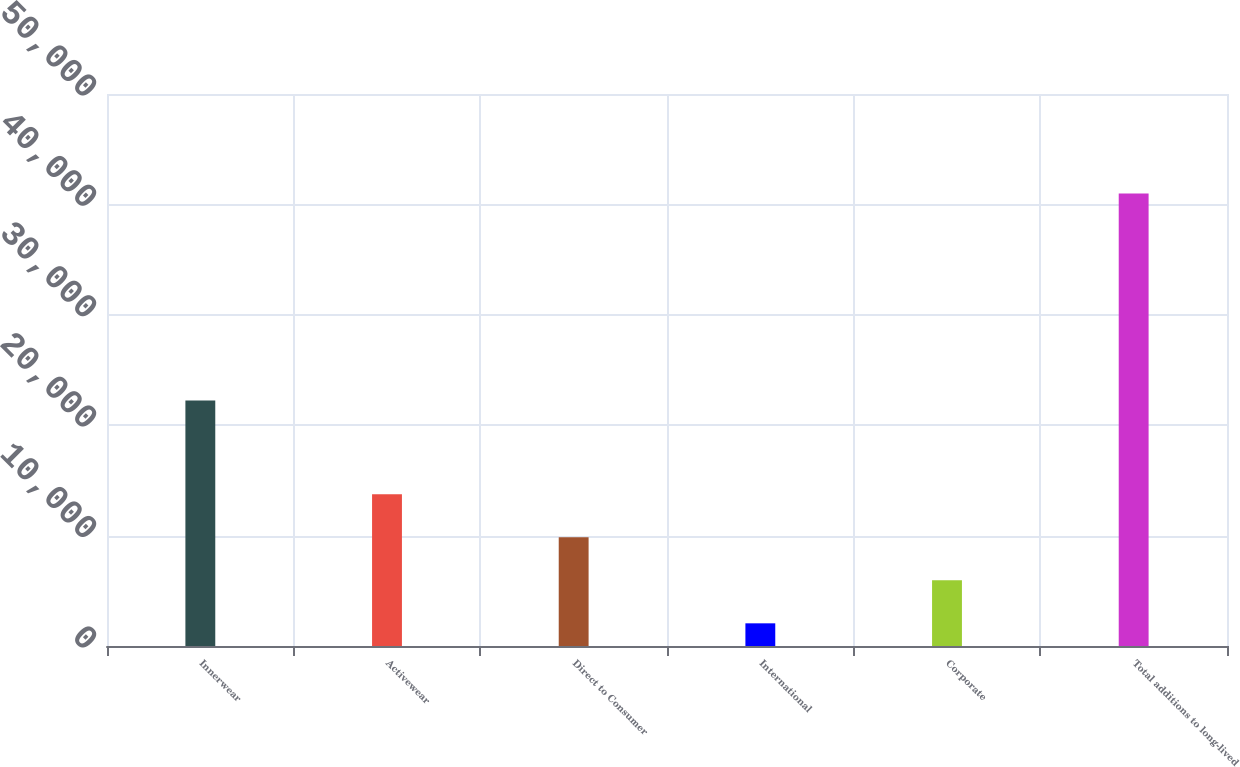Convert chart to OTSL. <chart><loc_0><loc_0><loc_500><loc_500><bar_chart><fcel>Innerwear<fcel>Activewear<fcel>Direct to Consumer<fcel>International<fcel>Corporate<fcel>Total additions to long-lived<nl><fcel>22241<fcel>13735.1<fcel>9841.4<fcel>2054<fcel>5947.7<fcel>40991<nl></chart> 